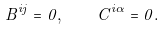<formula> <loc_0><loc_0><loc_500><loc_500>B ^ { i j } = 0 , \quad C ^ { i \alpha } = 0 .</formula> 